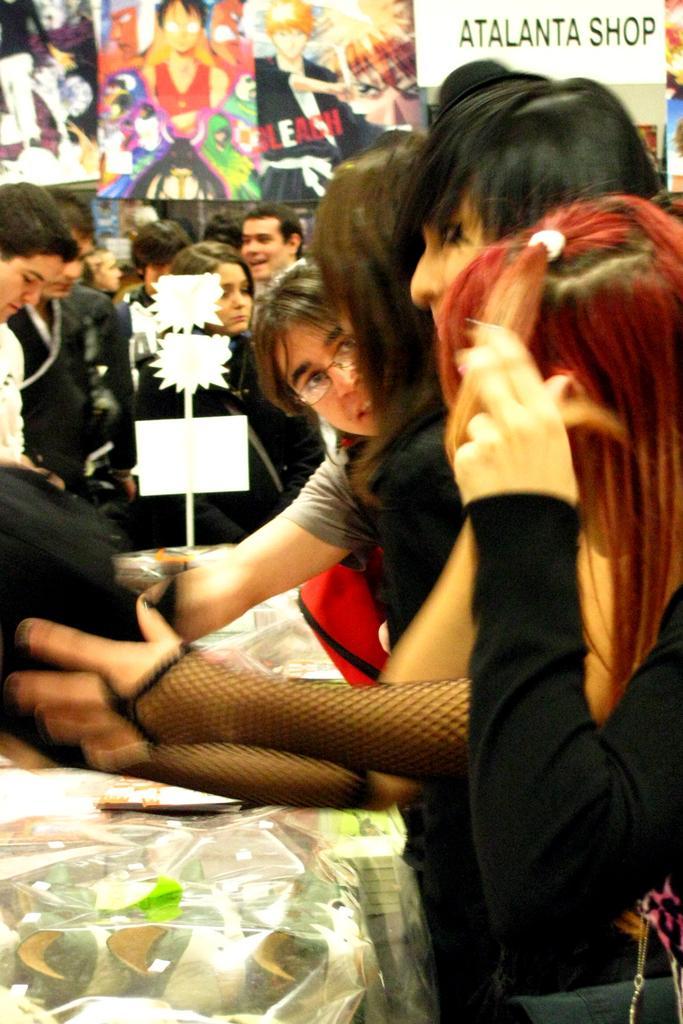Can you describe this image briefly? In this picture we can see some people standing, in the background there are some posters, we can see a board here. 